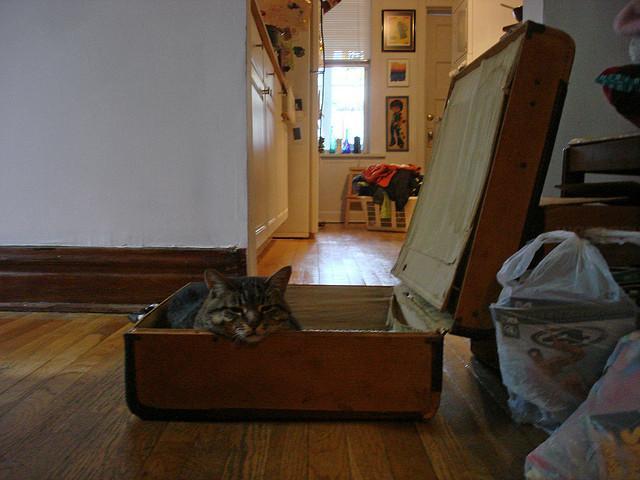How many people are dressed for surfing?
Give a very brief answer. 0. 